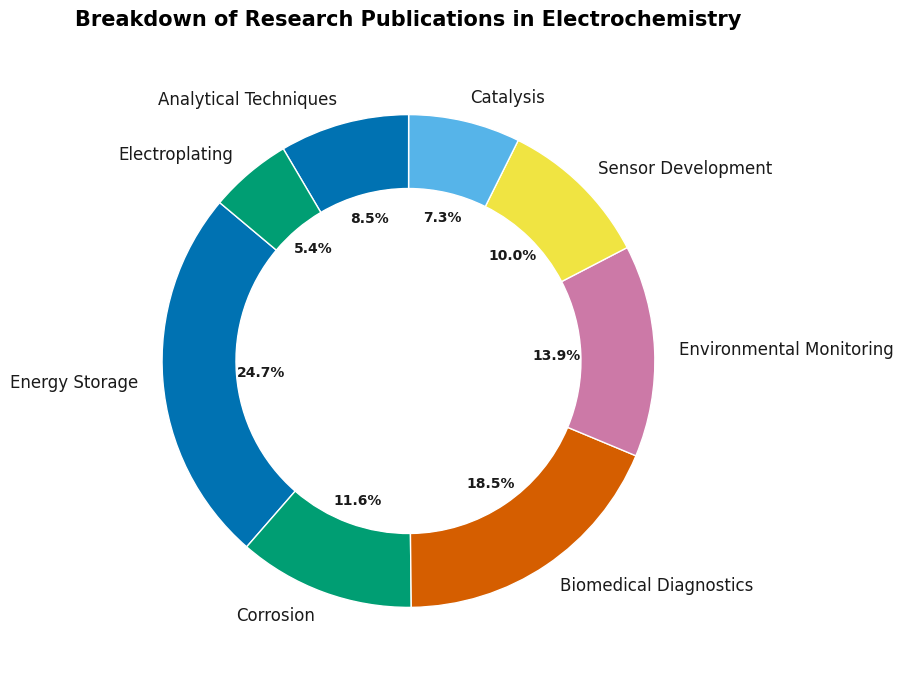Which application area has the highest number of research publications? Look at the pie chart and identify the segment with the largest percentage value. "Energy Storage" leads with 3200 publications, which is the highest among all segments.
Answer: Energy Storage Which two application areas together make up around half of the total research publications? Add the percentages of different segments displayed on the pie chart. "Energy Storage" (35.2%) and "Biomedical Diagnostics" (26.4%) together make up 61.6%, which is more than half. Thus, consider Energy Storage and Biomedical Diagnostics.
Answer: Energy Storage and Biomedical Diagnostics How does the number of publications in Environmental Monitoring compare with Biomedical Diagnostics? Find the segments for "Environmental Monitoring" and "Biomedical Diagnostics" on the pie chart. "Biomedical Diagnostics" has a larger percentage (26.4% vs. 19.8%). Hence, the number for Environmental Monitoring is less.
Answer: Environmental Monitoring has fewer publications What is the combined number of publications for the categories with the smallest and largest sections in the pie chart? Identify the smallest (Electroplating with 700 publications) and largest (Energy Storage with 3200 publications). Combine the two numbers: 700 + 3200 = 3900.
Answer: 3900 Which application area has slightly more publications than Sensor Development? Compare the segments for "Sensor Development" and identify the one slightly larger. "Analytical Techniques" (11.0%) has a slightly higher percentage than "Sensor Development" (14.3%).
Answer: Environmental Monitoring If the total number of research publications is 13000, how many publications are dedicated to Corrosion? The provided data shows Corrosion has 1500 publications. The pie chart shows Corrosion percentage. Verifying this by (1500/13000)*100% ≈ 11.5%.
Answer: 1500 What percentage of the total research publications is dedicated to the top three application areas combined? Sum up the percentages of the top three application areas: Energy Storage (35.2%), Biomedical Diagnostics (26.4%), and Environmental Monitoring (19.8%). The total is 35.2 + 26.4 + 19.8 = 81.4%.
Answer: 81.4% Which application area has the closest number of publications to Catalysis? Identify "Catalysis" (950 publications) and find the closest number in the pie chart. "Electroplating" with 700 publications is the nearest to 950.
Answer: Electroplating 